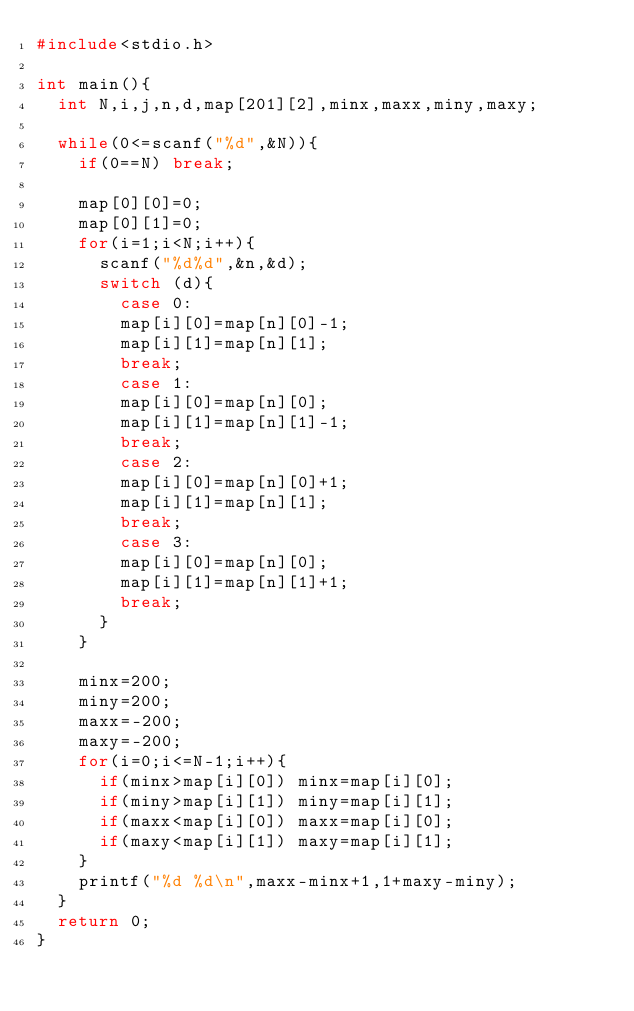Convert code to text. <code><loc_0><loc_0><loc_500><loc_500><_C++_>#include<stdio.h>

int main(){
	int N,i,j,n,d,map[201][2],minx,maxx,miny,maxy;
	
	while(0<=scanf("%d",&N)){
		if(0==N) break;
		
		map[0][0]=0;
		map[0][1]=0;
		for(i=1;i<N;i++){
			scanf("%d%d",&n,&d);
			switch (d){
			  case 0:
				map[i][0]=map[n][0]-1;
				map[i][1]=map[n][1];
				break;
			  case 1:
				map[i][0]=map[n][0];
				map[i][1]=map[n][1]-1;
				break;
			  case 2:
				map[i][0]=map[n][0]+1;
				map[i][1]=map[n][1];
				break;			  
			  case 3:
				map[i][0]=map[n][0];
				map[i][1]=map[n][1]+1;
				break;
			}
		}
		
		minx=200;
		miny=200;
		maxx=-200;
		maxy=-200;
		for(i=0;i<=N-1;i++){
			if(minx>map[i][0]) minx=map[i][0];
			if(miny>map[i][1]) miny=map[i][1];
			if(maxx<map[i][0]) maxx=map[i][0];
			if(maxy<map[i][1]) maxy=map[i][1];
		}
		printf("%d %d\n",maxx-minx+1,1+maxy-miny);
	}
	return 0;
}</code> 